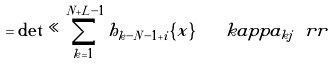<formula> <loc_0><loc_0><loc_500><loc_500>= \det \ll \sum _ { k = 1 } ^ { N + L - 1 } h _ { k - N - 1 + i } \{ x \} \ \ \ k a p p a _ { k j } \ r r</formula> 